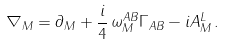<formula> <loc_0><loc_0><loc_500><loc_500>\nabla _ { M } = \partial _ { M } + \frac { i } { 4 } \, \omega _ { M } ^ { A B } \Gamma _ { A B } - i A _ { M } ^ { L } \, .</formula> 